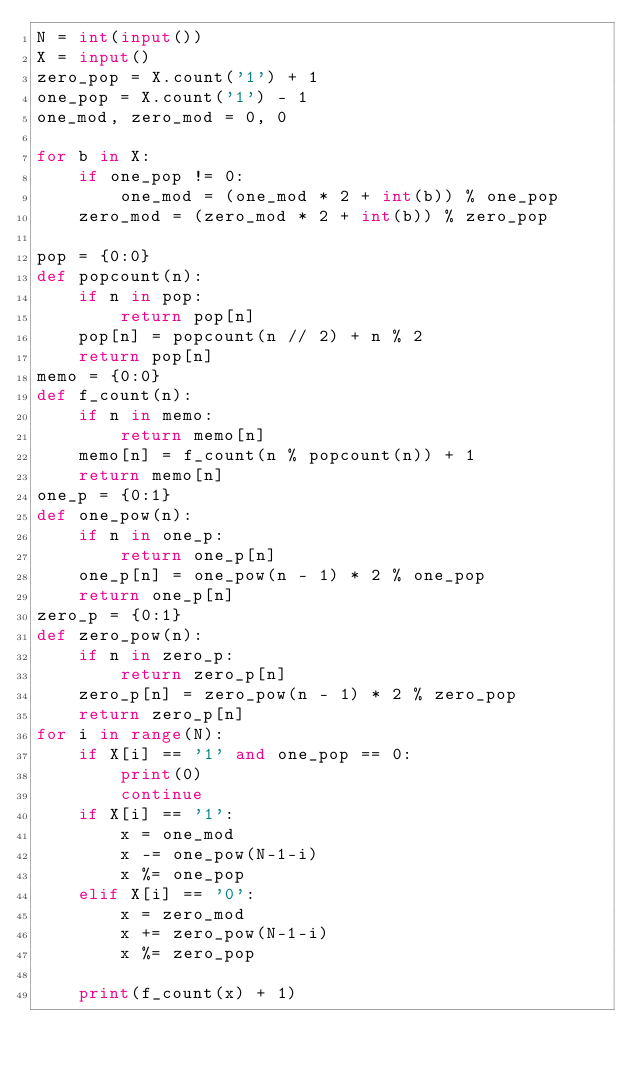Convert code to text. <code><loc_0><loc_0><loc_500><loc_500><_Python_>N = int(input())
X = input()
zero_pop = X.count('1') + 1
one_pop = X.count('1') - 1
one_mod, zero_mod = 0, 0

for b in X:
    if one_pop != 0:
        one_mod = (one_mod * 2 + int(b)) % one_pop
    zero_mod = (zero_mod * 2 + int(b)) % zero_pop

pop = {0:0}
def popcount(n):
    if n in pop:
        return pop[n]
    pop[n] = popcount(n // 2) + n % 2
    return pop[n]
memo = {0:0}
def f_count(n):
    if n in memo:
        return memo[n]
    memo[n] = f_count(n % popcount(n)) + 1
    return memo[n]
one_p = {0:1}
def one_pow(n):
    if n in one_p:
        return one_p[n]
    one_p[n] = one_pow(n - 1) * 2 % one_pop
    return one_p[n]
zero_p = {0:1}
def zero_pow(n):
    if n in zero_p:
        return zero_p[n]
    zero_p[n] = zero_pow(n - 1) * 2 % zero_pop
    return zero_p[n]
for i in range(N):
    if X[i] == '1' and one_pop == 0:
        print(0)
        continue
    if X[i] == '1':
        x = one_mod
        x -= one_pow(N-1-i)
        x %= one_pop
    elif X[i] == '0':
        x = zero_mod
        x += zero_pow(N-1-i)
        x %= zero_pop
    
    print(f_count(x) + 1)</code> 